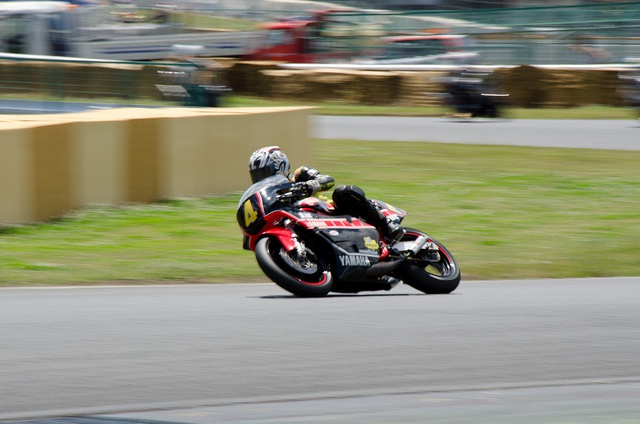Describe the objects in this image and their specific colors. I can see motorcycle in blue, black, gray, darkgray, and lightgray tones, truck in blue, gray, darkgray, maroon, and black tones, and people in blue, black, olive, darkgray, and lightgray tones in this image. 